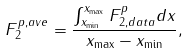<formula> <loc_0><loc_0><loc_500><loc_500>F _ { 2 } ^ { p , a v e } = \frac { \int _ { x _ { \min } } ^ { x _ { \max } } F _ { 2 , d a t a } ^ { p } d x } { x _ { \max } - x _ { \min } } ,</formula> 